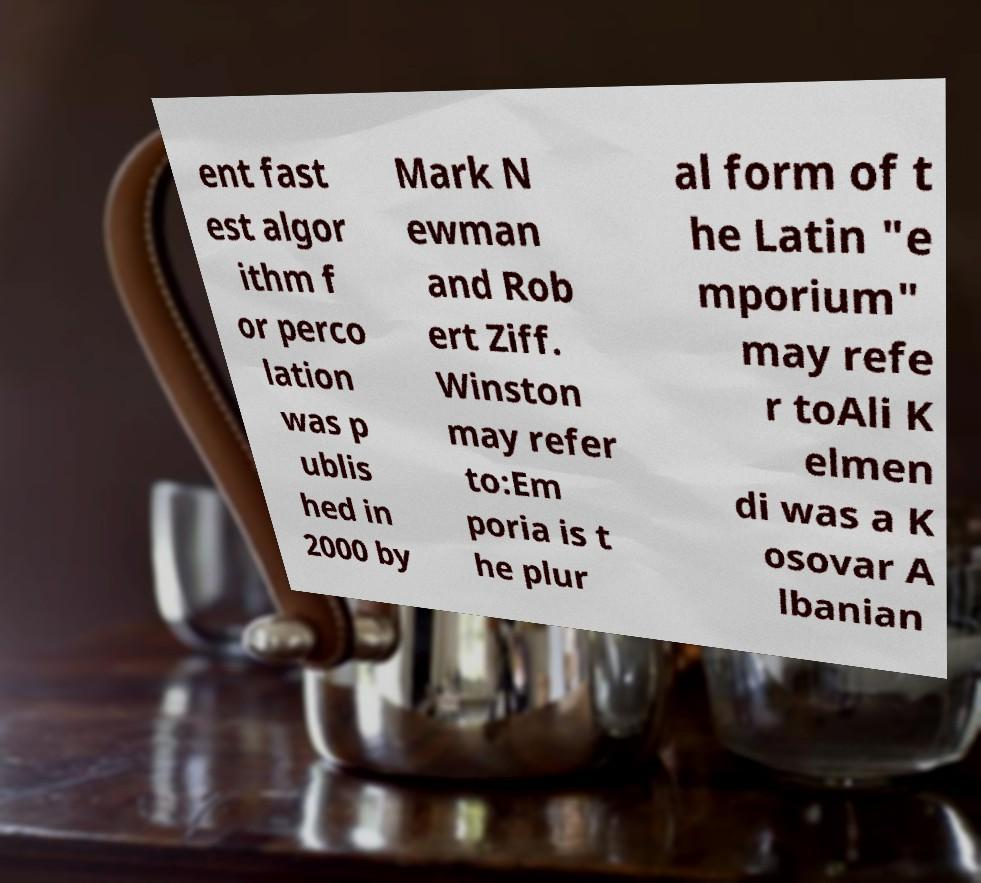Please identify and transcribe the text found in this image. ent fast est algor ithm f or perco lation was p ublis hed in 2000 by Mark N ewman and Rob ert Ziff. Winston may refer to:Em poria is t he plur al form of t he Latin "e mporium" may refe r toAli K elmen di was a K osovar A lbanian 